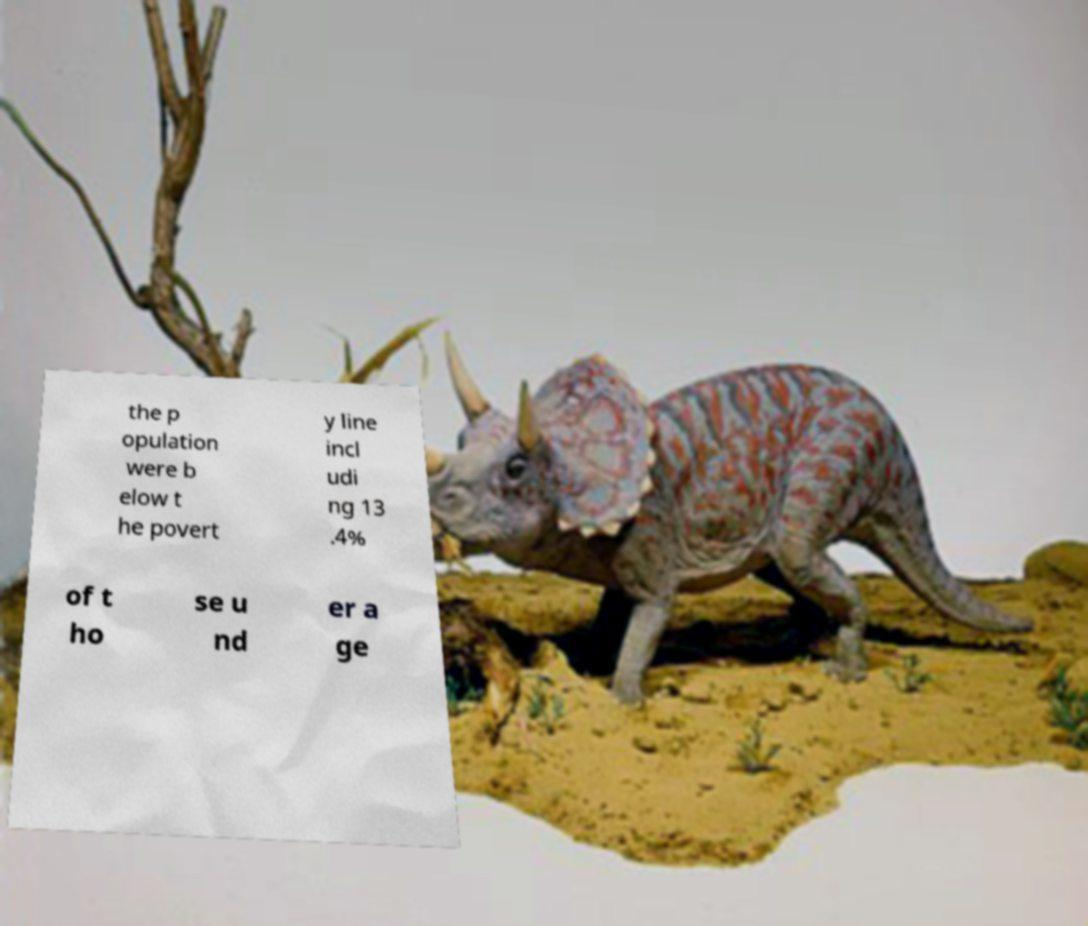What messages or text are displayed in this image? I need them in a readable, typed format. the p opulation were b elow t he povert y line incl udi ng 13 .4% of t ho se u nd er a ge 